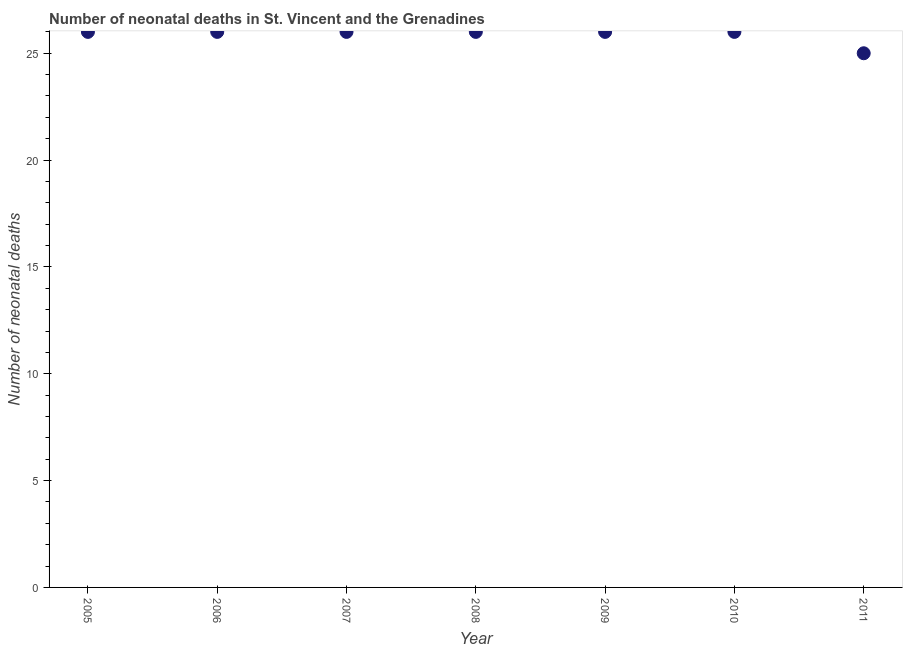What is the number of neonatal deaths in 2010?
Offer a very short reply. 26. Across all years, what is the maximum number of neonatal deaths?
Offer a very short reply. 26. Across all years, what is the minimum number of neonatal deaths?
Your response must be concise. 25. In which year was the number of neonatal deaths minimum?
Your answer should be very brief. 2011. What is the sum of the number of neonatal deaths?
Your answer should be compact. 181. What is the difference between the number of neonatal deaths in 2010 and 2011?
Your answer should be very brief. 1. What is the average number of neonatal deaths per year?
Keep it short and to the point. 25.86. What is the median number of neonatal deaths?
Keep it short and to the point. 26. Do a majority of the years between 2009 and 2010 (inclusive) have number of neonatal deaths greater than 16 ?
Provide a short and direct response. Yes. What is the ratio of the number of neonatal deaths in 2008 to that in 2011?
Your answer should be very brief. 1.04. Is the difference between the number of neonatal deaths in 2007 and 2010 greater than the difference between any two years?
Make the answer very short. No. Is the sum of the number of neonatal deaths in 2005 and 2009 greater than the maximum number of neonatal deaths across all years?
Make the answer very short. Yes. What is the difference between the highest and the lowest number of neonatal deaths?
Give a very brief answer. 1. In how many years, is the number of neonatal deaths greater than the average number of neonatal deaths taken over all years?
Offer a very short reply. 6. What is the difference between two consecutive major ticks on the Y-axis?
Give a very brief answer. 5. Does the graph contain grids?
Give a very brief answer. No. What is the title of the graph?
Ensure brevity in your answer.  Number of neonatal deaths in St. Vincent and the Grenadines. What is the label or title of the X-axis?
Your answer should be compact. Year. What is the label or title of the Y-axis?
Make the answer very short. Number of neonatal deaths. What is the Number of neonatal deaths in 2005?
Your response must be concise. 26. What is the Number of neonatal deaths in 2007?
Ensure brevity in your answer.  26. What is the Number of neonatal deaths in 2009?
Make the answer very short. 26. What is the difference between the Number of neonatal deaths in 2005 and 2007?
Make the answer very short. 0. What is the difference between the Number of neonatal deaths in 2005 and 2009?
Make the answer very short. 0. What is the difference between the Number of neonatal deaths in 2005 and 2010?
Offer a very short reply. 0. What is the difference between the Number of neonatal deaths in 2005 and 2011?
Keep it short and to the point. 1. What is the difference between the Number of neonatal deaths in 2006 and 2007?
Offer a very short reply. 0. What is the difference between the Number of neonatal deaths in 2006 and 2008?
Ensure brevity in your answer.  0. What is the difference between the Number of neonatal deaths in 2006 and 2010?
Provide a succinct answer. 0. What is the difference between the Number of neonatal deaths in 2007 and 2008?
Give a very brief answer. 0. What is the difference between the Number of neonatal deaths in 2007 and 2009?
Offer a very short reply. 0. What is the difference between the Number of neonatal deaths in 2007 and 2010?
Provide a succinct answer. 0. What is the difference between the Number of neonatal deaths in 2007 and 2011?
Make the answer very short. 1. What is the difference between the Number of neonatal deaths in 2008 and 2010?
Offer a terse response. 0. What is the difference between the Number of neonatal deaths in 2010 and 2011?
Your answer should be very brief. 1. What is the ratio of the Number of neonatal deaths in 2005 to that in 2008?
Offer a very short reply. 1. What is the ratio of the Number of neonatal deaths in 2005 to that in 2009?
Make the answer very short. 1. What is the ratio of the Number of neonatal deaths in 2005 to that in 2011?
Provide a succinct answer. 1.04. What is the ratio of the Number of neonatal deaths in 2006 to that in 2008?
Offer a terse response. 1. What is the ratio of the Number of neonatal deaths in 2006 to that in 2009?
Make the answer very short. 1. What is the ratio of the Number of neonatal deaths in 2007 to that in 2008?
Provide a short and direct response. 1. What is the ratio of the Number of neonatal deaths in 2007 to that in 2009?
Your answer should be compact. 1. What is the ratio of the Number of neonatal deaths in 2008 to that in 2010?
Provide a succinct answer. 1. What is the ratio of the Number of neonatal deaths in 2008 to that in 2011?
Offer a very short reply. 1.04. What is the ratio of the Number of neonatal deaths in 2009 to that in 2010?
Provide a succinct answer. 1. What is the ratio of the Number of neonatal deaths in 2010 to that in 2011?
Keep it short and to the point. 1.04. 